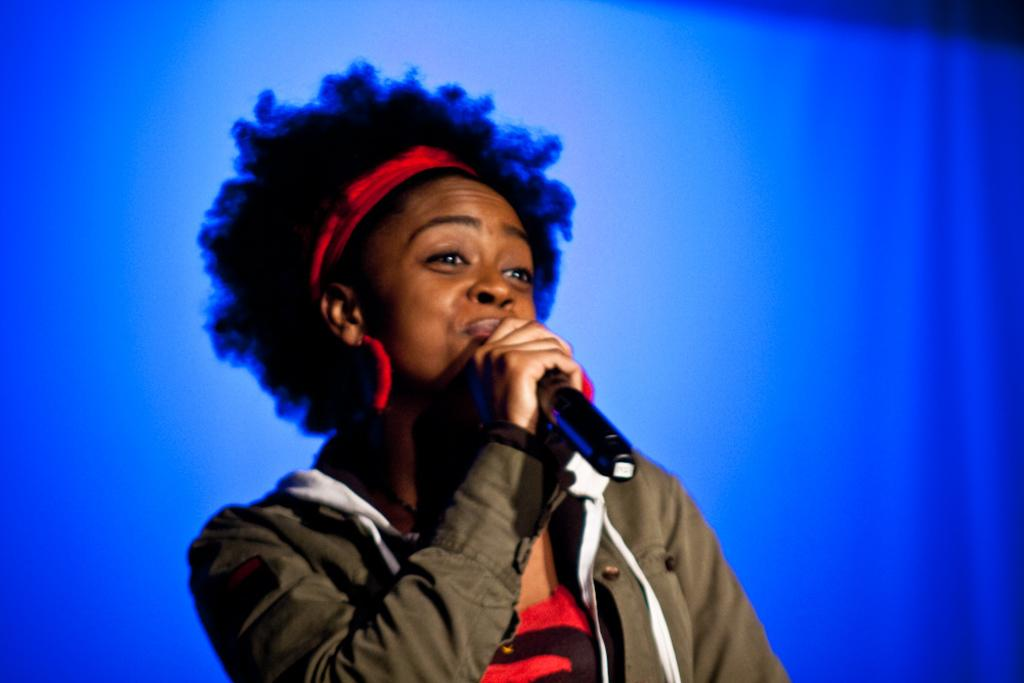Who is the main subject in the image? There is a lady in the image. What is the lady wearing on her upper body? The lady is wearing a grey jacket and a red t-shirt. What is the lady holding in her right hand? The lady is holding a mic in her right hand. What can be seen on the lady's head? The lady has a red color band on her head. What color is the background of the image? The background of the image is blue. Can you tell me how many ants are crawling on the lady's arm in the image? There are no ants present in the image, so it is not possible to determine how many might be crawling on the lady's arm. What type of eggnog is the lady drinking in the image? There is no eggnog present in the image, so it cannot be determined what type might be consumed. 